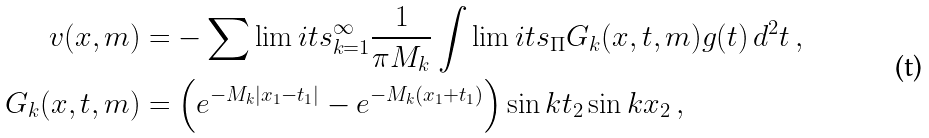Convert formula to latex. <formula><loc_0><loc_0><loc_500><loc_500>v ( x , m ) & = - \sum \lim i t s _ { k = 1 } ^ { \infty } \frac { 1 } { \pi M _ { k } } \int \lim i t s _ { \Pi } G _ { k } ( x , t , m ) g ( t ) \, d ^ { 2 } t \, , \\ G _ { k } ( x , t , m ) & = \left ( e ^ { - M _ { k } | x _ { 1 } - t _ { 1 } | } - e ^ { - M _ { k } ( x _ { 1 } + t _ { 1 } ) } \right ) \sin k t _ { 2 } \sin k x _ { 2 } \, ,</formula> 